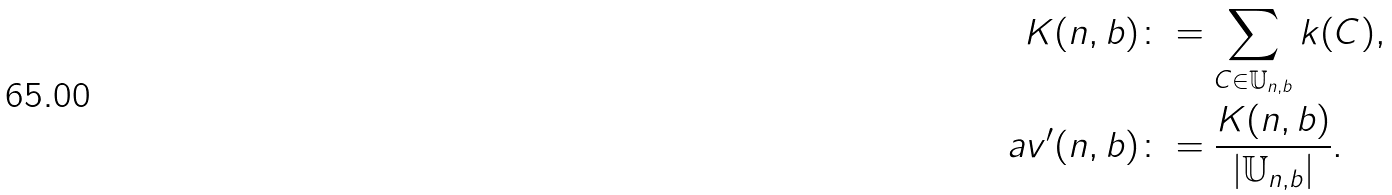<formula> <loc_0><loc_0><loc_500><loc_500>K ( n , b ) & \colon = \sum _ { C \in \mathbb { U } _ { n , b } } k ( C ) , \\ a v ^ { \prime } ( n , b ) & \colon = \frac { K ( n , b ) } { | \mathbb { U } _ { n , b } | } .</formula> 